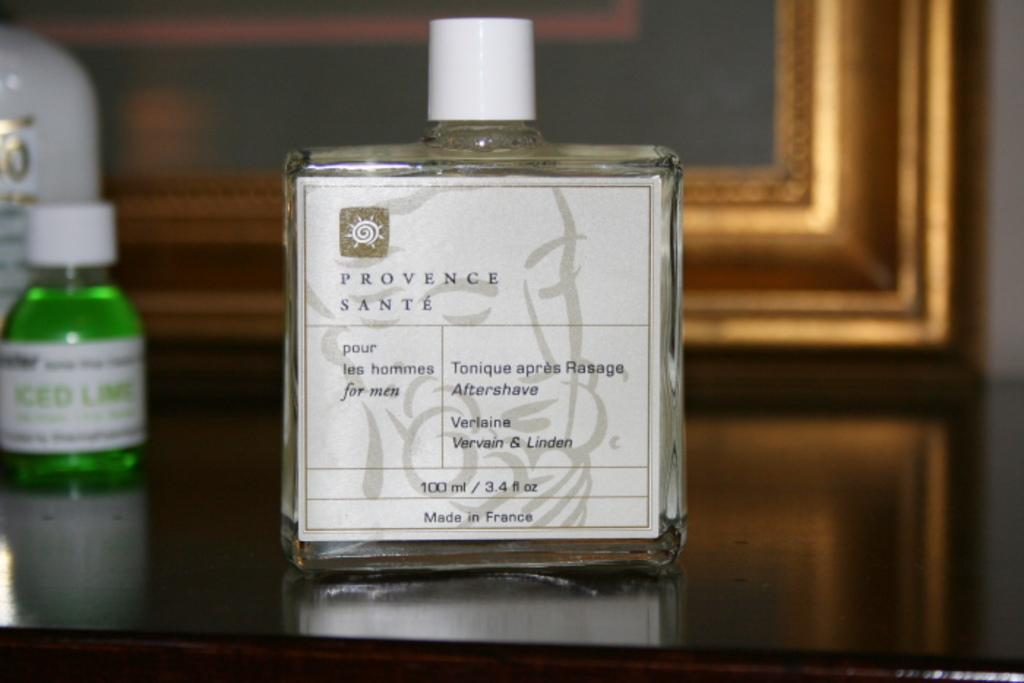<image>
Summarize the visual content of the image. A bottle with a white label that is 100 ml of aftershave 